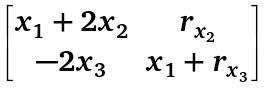<formula> <loc_0><loc_0><loc_500><loc_500>\begin{bmatrix} x _ { 1 } + 2 x _ { 2 } & r _ { x _ { 2 } } \\ - 2 x _ { 3 } & x _ { 1 } + r _ { x _ { 3 } } \end{bmatrix}</formula> 